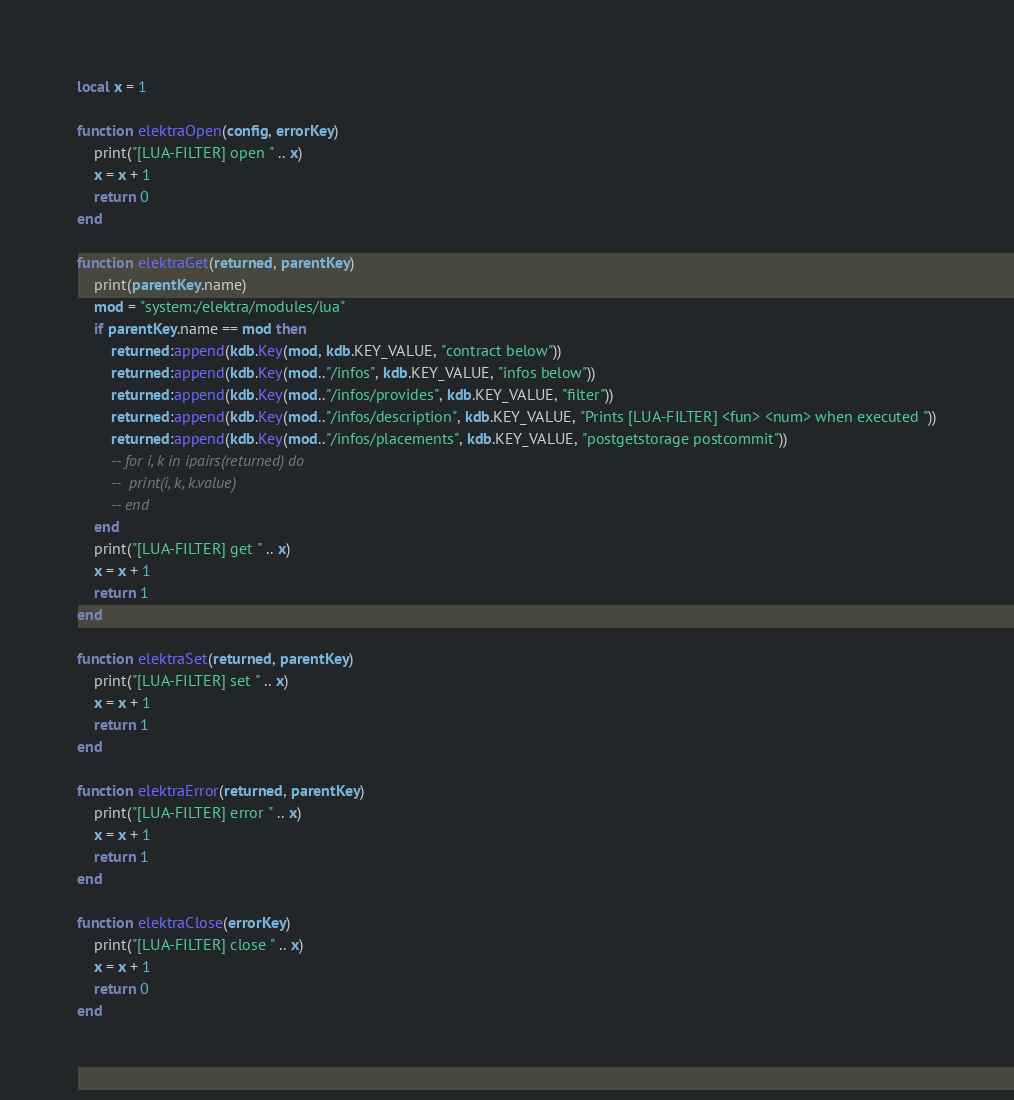<code> <loc_0><loc_0><loc_500><loc_500><_Lua_>local x = 1

function elektraOpen(config, errorKey)
	print("[LUA-FILTER] open " .. x)
	x = x + 1
	return 0
end

function elektraGet(returned, parentKey)
	print(parentKey.name)
	mod = "system:/elektra/modules/lua"
	if parentKey.name == mod then
		returned:append(kdb.Key(mod, kdb.KEY_VALUE, "contract below"))
		returned:append(kdb.Key(mod.."/infos", kdb.KEY_VALUE, "infos below"))
		returned:append(kdb.Key(mod.."/infos/provides", kdb.KEY_VALUE, "filter"))
		returned:append(kdb.Key(mod.."/infos/description", kdb.KEY_VALUE, "Prints [LUA-FILTER] <fun> <num> when executed "))
		returned:append(kdb.Key(mod.."/infos/placements", kdb.KEY_VALUE, "postgetstorage postcommit"))
		-- for i, k in ipairs(returned) do
		-- 	print(i, k, k.value)
		-- end
	end
	print("[LUA-FILTER] get " .. x)
	x = x + 1
	return 1
end

function elektraSet(returned, parentKey)
	print("[LUA-FILTER] set " .. x)
	x = x + 1
	return 1
end

function elektraError(returned, parentKey)
	print("[LUA-FILTER] error " .. x)
	x = x + 1
	return 1
end

function elektraClose(errorKey)
	print("[LUA-FILTER] close " .. x)
	x = x + 1
	return 0
end
</code> 